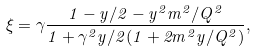<formula> <loc_0><loc_0><loc_500><loc_500>\xi = \gamma \frac { 1 - y / 2 - y ^ { 2 } m ^ { 2 } / Q ^ { 2 } } { 1 + \gamma ^ { 2 } y / 2 ( 1 + 2 m ^ { 2 } y / Q ^ { 2 } ) } ,</formula> 